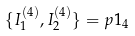<formula> <loc_0><loc_0><loc_500><loc_500>\{ I _ { 1 } ^ { ( 4 ) } , I _ { 2 } ^ { ( 4 ) } \} = p 1 _ { 4 } \</formula> 